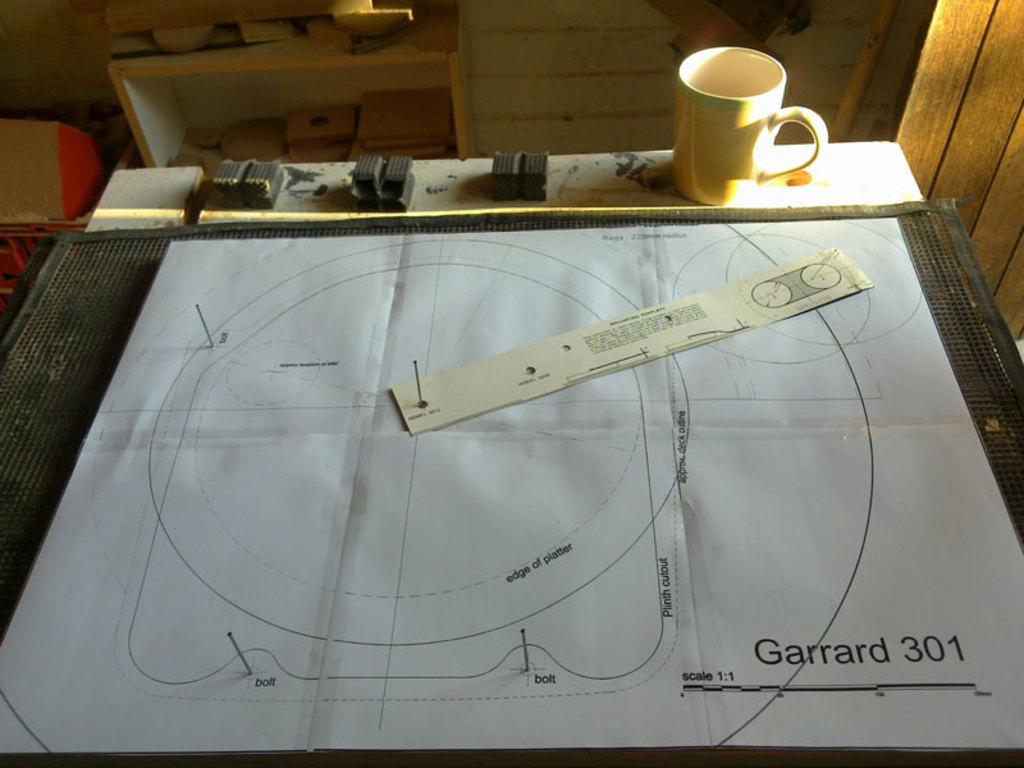Provide a one-sentence caption for the provided image. A drawing with Garrard 301 in the lower right corner. 